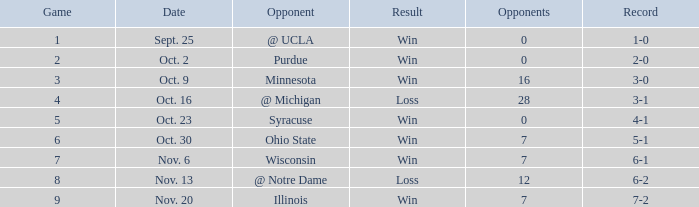How many wins or losses were there when the record was 3-0? 1.0. 